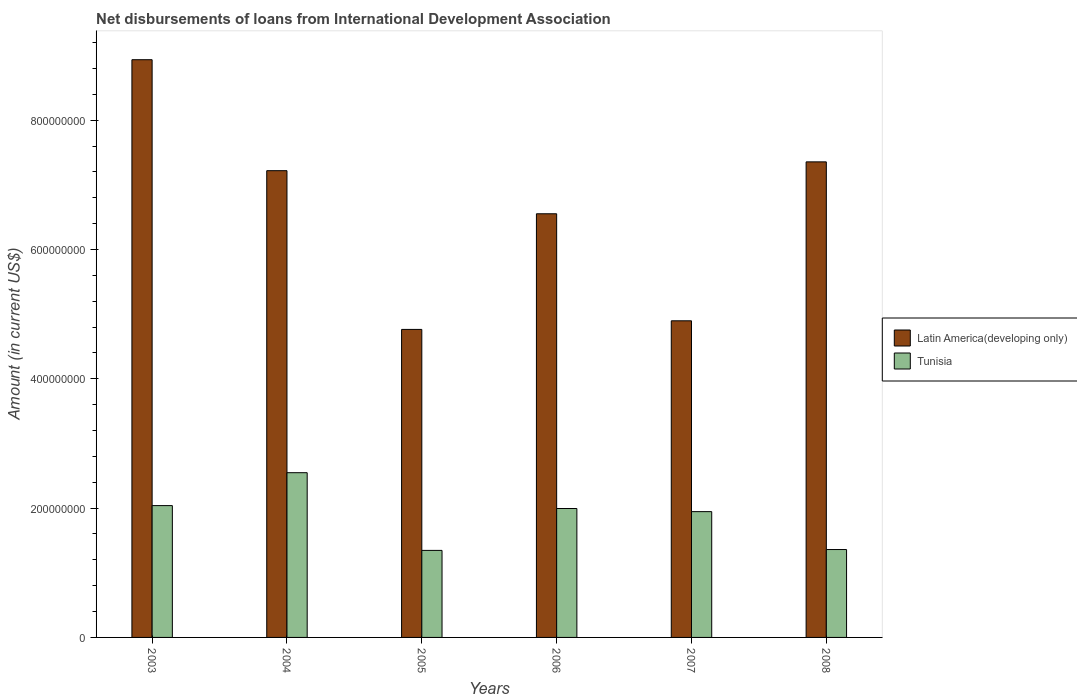How many different coloured bars are there?
Your answer should be compact. 2. Are the number of bars per tick equal to the number of legend labels?
Ensure brevity in your answer.  Yes. Are the number of bars on each tick of the X-axis equal?
Offer a very short reply. Yes. What is the amount of loans disbursed in Latin America(developing only) in 2008?
Make the answer very short. 7.36e+08. Across all years, what is the maximum amount of loans disbursed in Latin America(developing only)?
Provide a short and direct response. 8.94e+08. Across all years, what is the minimum amount of loans disbursed in Latin America(developing only)?
Provide a succinct answer. 4.76e+08. In which year was the amount of loans disbursed in Latin America(developing only) minimum?
Your response must be concise. 2005. What is the total amount of loans disbursed in Latin America(developing only) in the graph?
Ensure brevity in your answer.  3.97e+09. What is the difference between the amount of loans disbursed in Tunisia in 2003 and that in 2005?
Provide a succinct answer. 6.93e+07. What is the difference between the amount of loans disbursed in Latin America(developing only) in 2007 and the amount of loans disbursed in Tunisia in 2005?
Give a very brief answer. 3.55e+08. What is the average amount of loans disbursed in Latin America(developing only) per year?
Your response must be concise. 6.62e+08. In the year 2006, what is the difference between the amount of loans disbursed in Tunisia and amount of loans disbursed in Latin America(developing only)?
Provide a succinct answer. -4.56e+08. In how many years, is the amount of loans disbursed in Tunisia greater than 400000000 US$?
Offer a very short reply. 0. What is the ratio of the amount of loans disbursed in Latin America(developing only) in 2003 to that in 2008?
Your response must be concise. 1.21. Is the difference between the amount of loans disbursed in Tunisia in 2004 and 2006 greater than the difference between the amount of loans disbursed in Latin America(developing only) in 2004 and 2006?
Provide a short and direct response. No. What is the difference between the highest and the second highest amount of loans disbursed in Tunisia?
Offer a very short reply. 5.09e+07. What is the difference between the highest and the lowest amount of loans disbursed in Tunisia?
Give a very brief answer. 1.20e+08. What does the 1st bar from the left in 2005 represents?
Provide a short and direct response. Latin America(developing only). What does the 2nd bar from the right in 2006 represents?
Your answer should be compact. Latin America(developing only). How many bars are there?
Provide a short and direct response. 12. Are all the bars in the graph horizontal?
Offer a terse response. No. How many years are there in the graph?
Offer a very short reply. 6. What is the difference between two consecutive major ticks on the Y-axis?
Give a very brief answer. 2.00e+08. Are the values on the major ticks of Y-axis written in scientific E-notation?
Your response must be concise. No. Does the graph contain any zero values?
Provide a succinct answer. No. Does the graph contain grids?
Give a very brief answer. No. Where does the legend appear in the graph?
Make the answer very short. Center right. How are the legend labels stacked?
Give a very brief answer. Vertical. What is the title of the graph?
Offer a very short reply. Net disbursements of loans from International Development Association. Does "Faeroe Islands" appear as one of the legend labels in the graph?
Ensure brevity in your answer.  No. What is the Amount (in current US$) in Latin America(developing only) in 2003?
Your answer should be very brief. 8.94e+08. What is the Amount (in current US$) of Tunisia in 2003?
Provide a short and direct response. 2.04e+08. What is the Amount (in current US$) of Latin America(developing only) in 2004?
Provide a short and direct response. 7.22e+08. What is the Amount (in current US$) of Tunisia in 2004?
Keep it short and to the point. 2.55e+08. What is the Amount (in current US$) in Latin America(developing only) in 2005?
Your answer should be compact. 4.76e+08. What is the Amount (in current US$) of Tunisia in 2005?
Keep it short and to the point. 1.35e+08. What is the Amount (in current US$) in Latin America(developing only) in 2006?
Provide a short and direct response. 6.55e+08. What is the Amount (in current US$) of Tunisia in 2006?
Give a very brief answer. 1.99e+08. What is the Amount (in current US$) in Latin America(developing only) in 2007?
Give a very brief answer. 4.90e+08. What is the Amount (in current US$) in Tunisia in 2007?
Your response must be concise. 1.95e+08. What is the Amount (in current US$) in Latin America(developing only) in 2008?
Provide a short and direct response. 7.36e+08. What is the Amount (in current US$) of Tunisia in 2008?
Your answer should be very brief. 1.36e+08. Across all years, what is the maximum Amount (in current US$) in Latin America(developing only)?
Keep it short and to the point. 8.94e+08. Across all years, what is the maximum Amount (in current US$) in Tunisia?
Offer a terse response. 2.55e+08. Across all years, what is the minimum Amount (in current US$) in Latin America(developing only)?
Keep it short and to the point. 4.76e+08. Across all years, what is the minimum Amount (in current US$) of Tunisia?
Make the answer very short. 1.35e+08. What is the total Amount (in current US$) of Latin America(developing only) in the graph?
Your response must be concise. 3.97e+09. What is the total Amount (in current US$) in Tunisia in the graph?
Your answer should be compact. 1.12e+09. What is the difference between the Amount (in current US$) of Latin America(developing only) in 2003 and that in 2004?
Ensure brevity in your answer.  1.72e+08. What is the difference between the Amount (in current US$) of Tunisia in 2003 and that in 2004?
Your answer should be very brief. -5.09e+07. What is the difference between the Amount (in current US$) in Latin America(developing only) in 2003 and that in 2005?
Offer a very short reply. 4.17e+08. What is the difference between the Amount (in current US$) of Tunisia in 2003 and that in 2005?
Make the answer very short. 6.93e+07. What is the difference between the Amount (in current US$) of Latin America(developing only) in 2003 and that in 2006?
Your response must be concise. 2.38e+08. What is the difference between the Amount (in current US$) in Tunisia in 2003 and that in 2006?
Make the answer very short. 4.48e+06. What is the difference between the Amount (in current US$) in Latin America(developing only) in 2003 and that in 2007?
Make the answer very short. 4.04e+08. What is the difference between the Amount (in current US$) of Tunisia in 2003 and that in 2007?
Ensure brevity in your answer.  9.31e+06. What is the difference between the Amount (in current US$) in Latin America(developing only) in 2003 and that in 2008?
Your answer should be very brief. 1.58e+08. What is the difference between the Amount (in current US$) of Tunisia in 2003 and that in 2008?
Your answer should be very brief. 6.79e+07. What is the difference between the Amount (in current US$) of Latin America(developing only) in 2004 and that in 2005?
Your answer should be very brief. 2.46e+08. What is the difference between the Amount (in current US$) of Tunisia in 2004 and that in 2005?
Your response must be concise. 1.20e+08. What is the difference between the Amount (in current US$) of Latin America(developing only) in 2004 and that in 2006?
Your response must be concise. 6.67e+07. What is the difference between the Amount (in current US$) in Tunisia in 2004 and that in 2006?
Make the answer very short. 5.54e+07. What is the difference between the Amount (in current US$) in Latin America(developing only) in 2004 and that in 2007?
Keep it short and to the point. 2.32e+08. What is the difference between the Amount (in current US$) in Tunisia in 2004 and that in 2007?
Offer a terse response. 6.02e+07. What is the difference between the Amount (in current US$) in Latin America(developing only) in 2004 and that in 2008?
Give a very brief answer. -1.36e+07. What is the difference between the Amount (in current US$) in Tunisia in 2004 and that in 2008?
Give a very brief answer. 1.19e+08. What is the difference between the Amount (in current US$) of Latin America(developing only) in 2005 and that in 2006?
Make the answer very short. -1.79e+08. What is the difference between the Amount (in current US$) in Tunisia in 2005 and that in 2006?
Keep it short and to the point. -6.48e+07. What is the difference between the Amount (in current US$) in Latin America(developing only) in 2005 and that in 2007?
Provide a succinct answer. -1.33e+07. What is the difference between the Amount (in current US$) in Tunisia in 2005 and that in 2007?
Provide a short and direct response. -6.00e+07. What is the difference between the Amount (in current US$) in Latin America(developing only) in 2005 and that in 2008?
Keep it short and to the point. -2.59e+08. What is the difference between the Amount (in current US$) of Tunisia in 2005 and that in 2008?
Give a very brief answer. -1.35e+06. What is the difference between the Amount (in current US$) in Latin America(developing only) in 2006 and that in 2007?
Your answer should be very brief. 1.66e+08. What is the difference between the Amount (in current US$) in Tunisia in 2006 and that in 2007?
Your response must be concise. 4.83e+06. What is the difference between the Amount (in current US$) of Latin America(developing only) in 2006 and that in 2008?
Offer a terse response. -8.03e+07. What is the difference between the Amount (in current US$) of Tunisia in 2006 and that in 2008?
Provide a succinct answer. 6.35e+07. What is the difference between the Amount (in current US$) of Latin America(developing only) in 2007 and that in 2008?
Offer a very short reply. -2.46e+08. What is the difference between the Amount (in current US$) of Tunisia in 2007 and that in 2008?
Make the answer very short. 5.86e+07. What is the difference between the Amount (in current US$) of Latin America(developing only) in 2003 and the Amount (in current US$) of Tunisia in 2004?
Your answer should be very brief. 6.39e+08. What is the difference between the Amount (in current US$) in Latin America(developing only) in 2003 and the Amount (in current US$) in Tunisia in 2005?
Provide a short and direct response. 7.59e+08. What is the difference between the Amount (in current US$) in Latin America(developing only) in 2003 and the Amount (in current US$) in Tunisia in 2006?
Offer a very short reply. 6.94e+08. What is the difference between the Amount (in current US$) in Latin America(developing only) in 2003 and the Amount (in current US$) in Tunisia in 2007?
Offer a very short reply. 6.99e+08. What is the difference between the Amount (in current US$) of Latin America(developing only) in 2003 and the Amount (in current US$) of Tunisia in 2008?
Keep it short and to the point. 7.58e+08. What is the difference between the Amount (in current US$) in Latin America(developing only) in 2004 and the Amount (in current US$) in Tunisia in 2005?
Make the answer very short. 5.87e+08. What is the difference between the Amount (in current US$) in Latin America(developing only) in 2004 and the Amount (in current US$) in Tunisia in 2006?
Your answer should be very brief. 5.23e+08. What is the difference between the Amount (in current US$) in Latin America(developing only) in 2004 and the Amount (in current US$) in Tunisia in 2007?
Offer a terse response. 5.27e+08. What is the difference between the Amount (in current US$) of Latin America(developing only) in 2004 and the Amount (in current US$) of Tunisia in 2008?
Offer a very short reply. 5.86e+08. What is the difference between the Amount (in current US$) in Latin America(developing only) in 2005 and the Amount (in current US$) in Tunisia in 2006?
Offer a very short reply. 2.77e+08. What is the difference between the Amount (in current US$) of Latin America(developing only) in 2005 and the Amount (in current US$) of Tunisia in 2007?
Provide a short and direct response. 2.82e+08. What is the difference between the Amount (in current US$) of Latin America(developing only) in 2005 and the Amount (in current US$) of Tunisia in 2008?
Provide a short and direct response. 3.40e+08. What is the difference between the Amount (in current US$) of Latin America(developing only) in 2006 and the Amount (in current US$) of Tunisia in 2007?
Offer a terse response. 4.61e+08. What is the difference between the Amount (in current US$) in Latin America(developing only) in 2006 and the Amount (in current US$) in Tunisia in 2008?
Provide a short and direct response. 5.19e+08. What is the difference between the Amount (in current US$) in Latin America(developing only) in 2007 and the Amount (in current US$) in Tunisia in 2008?
Keep it short and to the point. 3.54e+08. What is the average Amount (in current US$) in Latin America(developing only) per year?
Offer a very short reply. 6.62e+08. What is the average Amount (in current US$) of Tunisia per year?
Give a very brief answer. 1.87e+08. In the year 2003, what is the difference between the Amount (in current US$) of Latin America(developing only) and Amount (in current US$) of Tunisia?
Offer a terse response. 6.90e+08. In the year 2004, what is the difference between the Amount (in current US$) in Latin America(developing only) and Amount (in current US$) in Tunisia?
Your answer should be very brief. 4.67e+08. In the year 2005, what is the difference between the Amount (in current US$) in Latin America(developing only) and Amount (in current US$) in Tunisia?
Offer a very short reply. 3.42e+08. In the year 2006, what is the difference between the Amount (in current US$) of Latin America(developing only) and Amount (in current US$) of Tunisia?
Your response must be concise. 4.56e+08. In the year 2007, what is the difference between the Amount (in current US$) of Latin America(developing only) and Amount (in current US$) of Tunisia?
Keep it short and to the point. 2.95e+08. In the year 2008, what is the difference between the Amount (in current US$) in Latin America(developing only) and Amount (in current US$) in Tunisia?
Provide a short and direct response. 6.00e+08. What is the ratio of the Amount (in current US$) in Latin America(developing only) in 2003 to that in 2004?
Your response must be concise. 1.24. What is the ratio of the Amount (in current US$) of Tunisia in 2003 to that in 2004?
Your answer should be very brief. 0.8. What is the ratio of the Amount (in current US$) of Latin America(developing only) in 2003 to that in 2005?
Make the answer very short. 1.88. What is the ratio of the Amount (in current US$) of Tunisia in 2003 to that in 2005?
Offer a very short reply. 1.51. What is the ratio of the Amount (in current US$) of Latin America(developing only) in 2003 to that in 2006?
Give a very brief answer. 1.36. What is the ratio of the Amount (in current US$) of Tunisia in 2003 to that in 2006?
Make the answer very short. 1.02. What is the ratio of the Amount (in current US$) in Latin America(developing only) in 2003 to that in 2007?
Give a very brief answer. 1.82. What is the ratio of the Amount (in current US$) of Tunisia in 2003 to that in 2007?
Your answer should be compact. 1.05. What is the ratio of the Amount (in current US$) of Latin America(developing only) in 2003 to that in 2008?
Ensure brevity in your answer.  1.21. What is the ratio of the Amount (in current US$) of Tunisia in 2003 to that in 2008?
Offer a very short reply. 1.5. What is the ratio of the Amount (in current US$) of Latin America(developing only) in 2004 to that in 2005?
Ensure brevity in your answer.  1.52. What is the ratio of the Amount (in current US$) in Tunisia in 2004 to that in 2005?
Make the answer very short. 1.89. What is the ratio of the Amount (in current US$) in Latin America(developing only) in 2004 to that in 2006?
Give a very brief answer. 1.1. What is the ratio of the Amount (in current US$) of Tunisia in 2004 to that in 2006?
Your answer should be compact. 1.28. What is the ratio of the Amount (in current US$) of Latin America(developing only) in 2004 to that in 2007?
Provide a short and direct response. 1.47. What is the ratio of the Amount (in current US$) in Tunisia in 2004 to that in 2007?
Ensure brevity in your answer.  1.31. What is the ratio of the Amount (in current US$) in Latin America(developing only) in 2004 to that in 2008?
Your answer should be very brief. 0.98. What is the ratio of the Amount (in current US$) in Tunisia in 2004 to that in 2008?
Keep it short and to the point. 1.87. What is the ratio of the Amount (in current US$) of Latin America(developing only) in 2005 to that in 2006?
Ensure brevity in your answer.  0.73. What is the ratio of the Amount (in current US$) of Tunisia in 2005 to that in 2006?
Make the answer very short. 0.68. What is the ratio of the Amount (in current US$) of Latin America(developing only) in 2005 to that in 2007?
Provide a short and direct response. 0.97. What is the ratio of the Amount (in current US$) of Tunisia in 2005 to that in 2007?
Ensure brevity in your answer.  0.69. What is the ratio of the Amount (in current US$) in Latin America(developing only) in 2005 to that in 2008?
Your answer should be compact. 0.65. What is the ratio of the Amount (in current US$) in Latin America(developing only) in 2006 to that in 2007?
Your response must be concise. 1.34. What is the ratio of the Amount (in current US$) of Tunisia in 2006 to that in 2007?
Provide a succinct answer. 1.02. What is the ratio of the Amount (in current US$) in Latin America(developing only) in 2006 to that in 2008?
Offer a terse response. 0.89. What is the ratio of the Amount (in current US$) in Tunisia in 2006 to that in 2008?
Your answer should be very brief. 1.47. What is the ratio of the Amount (in current US$) of Latin America(developing only) in 2007 to that in 2008?
Your answer should be very brief. 0.67. What is the ratio of the Amount (in current US$) in Tunisia in 2007 to that in 2008?
Provide a short and direct response. 1.43. What is the difference between the highest and the second highest Amount (in current US$) of Latin America(developing only)?
Your answer should be compact. 1.58e+08. What is the difference between the highest and the second highest Amount (in current US$) of Tunisia?
Offer a terse response. 5.09e+07. What is the difference between the highest and the lowest Amount (in current US$) in Latin America(developing only)?
Your answer should be compact. 4.17e+08. What is the difference between the highest and the lowest Amount (in current US$) in Tunisia?
Your answer should be very brief. 1.20e+08. 